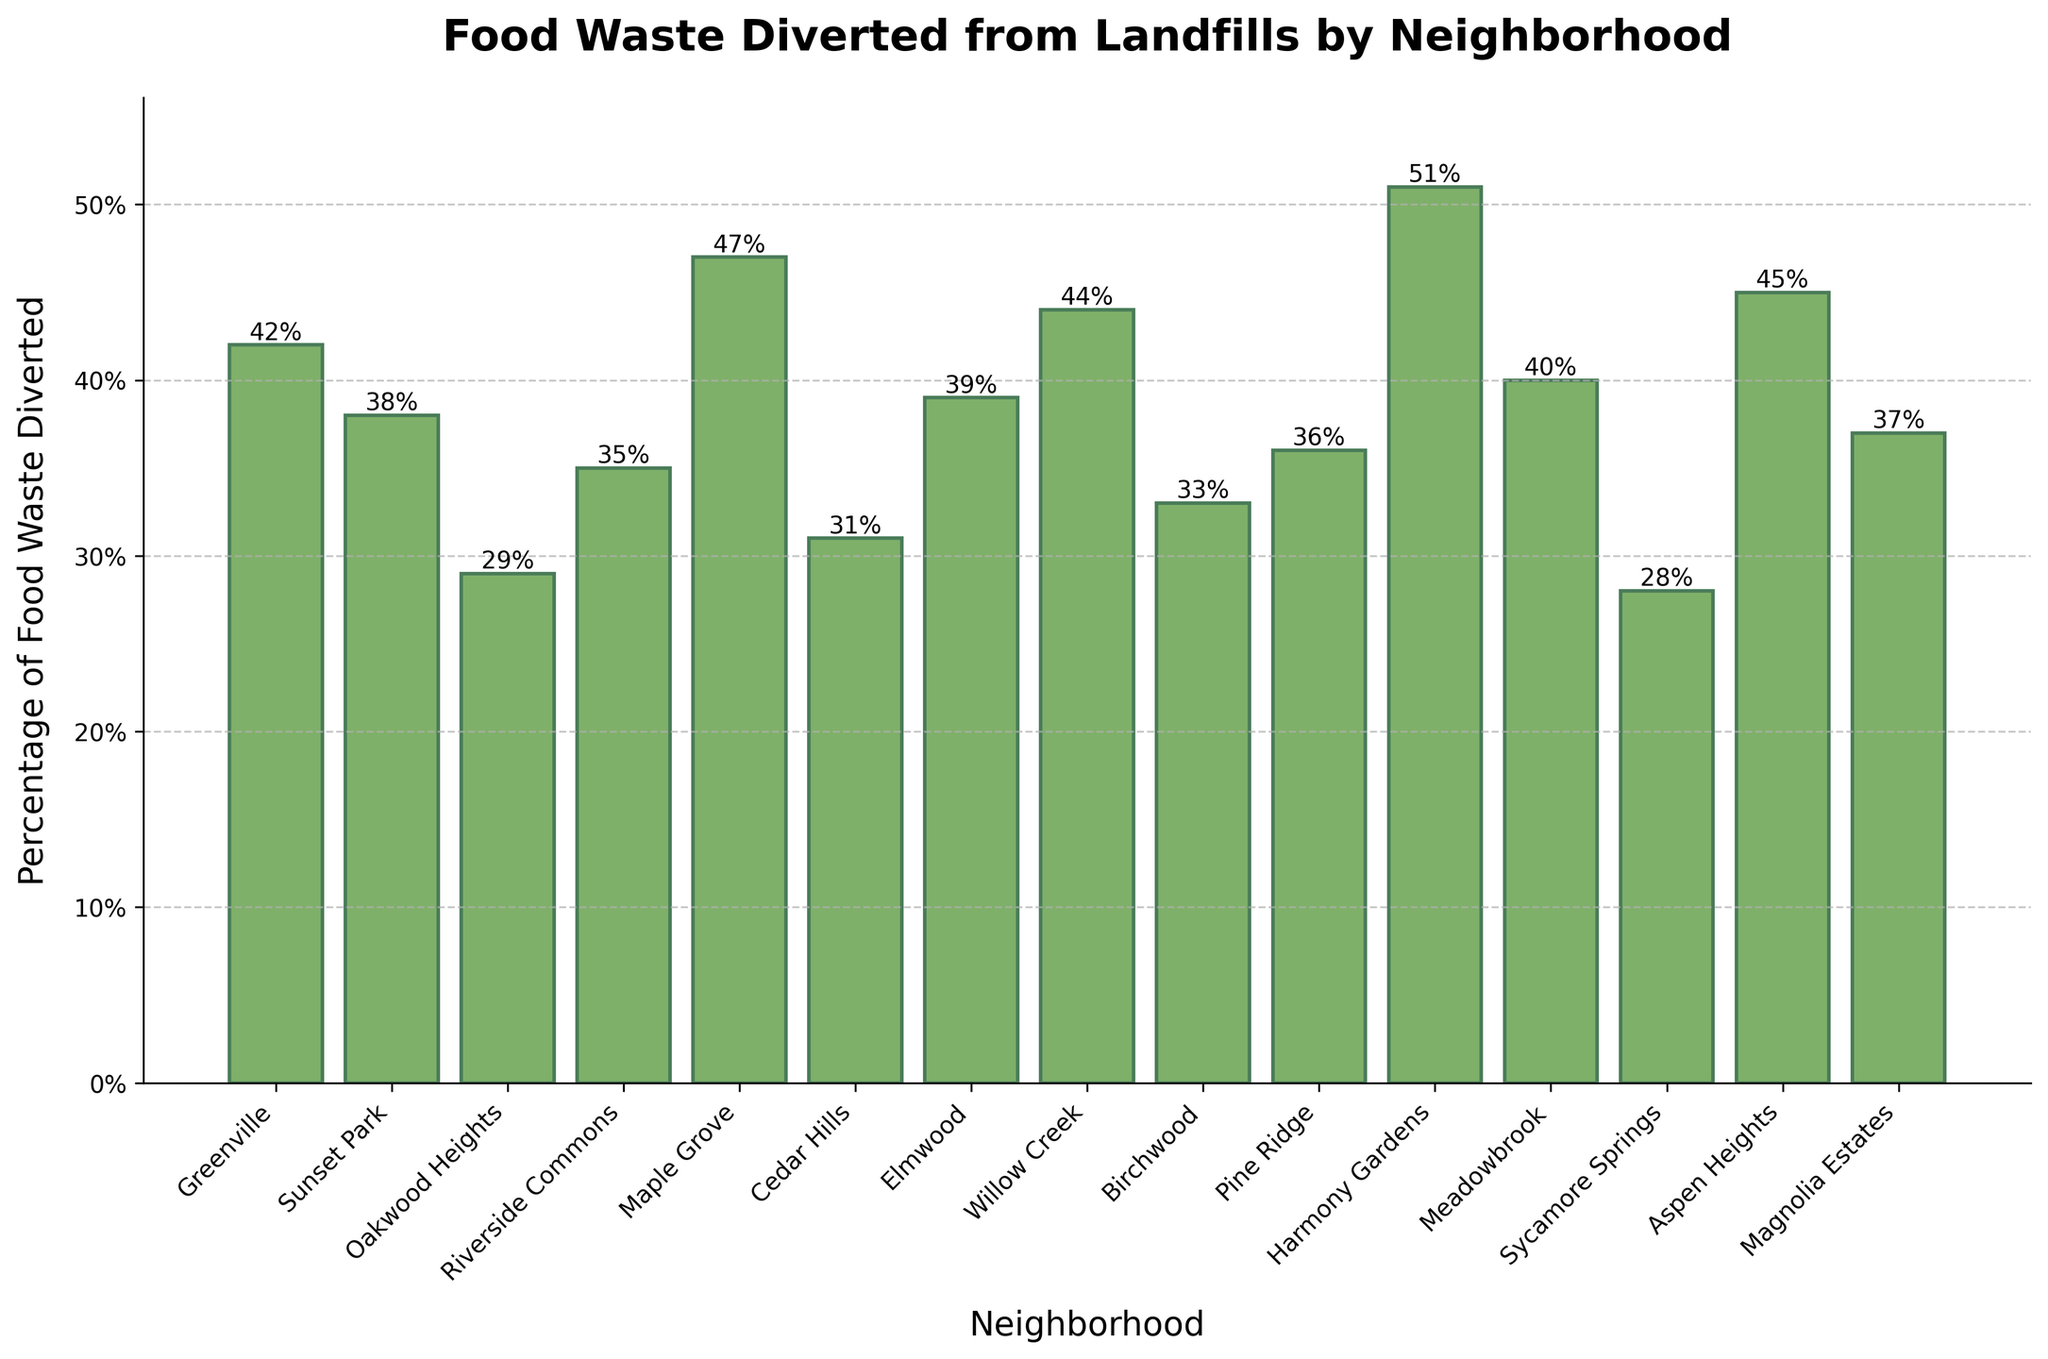Which neighborhood has the highest percentage of food waste diverted? The highest bar in the figure indicates the neighborhood with the highest percentage of food waste diverted. The label at the top of this bar shows "51%", corresponding to Harmony Gardens.
Answer: Harmony Gardens Which neighborhood has the lowest percentage of food waste diverted? The shortest bar indicates the neighborhood with the lowest percentage of food waste diverted. The label at the top of this bar shows "28%", corresponding to Sycamore Springs.
Answer: Sycamore Springs What is the difference between the highest and the lowest percentage of food waste diverted among the neighborhoods? The highest percentage is 51% (Harmony Gardens) and the lowest is 28% (Sycamore Springs). Subtracting the lowest value from the highest value gives 51% - 28% = 23%.
Answer: 23% How many neighborhoods have diverted between 30% and 40% of their food waste? Check the height of each bar and count those with values between 30% and 40% inclusive. The neighborhoods that fall in this range are Elmwood (39%), Pine Ridge (36%), Cedar Hills (31%), Magnolia Estates (37%), and Meadowbrook (40%) – a total of five.
Answer: 5 Which neighborhood has a percentage closest to the average percentage of food waste diverted across all neighborhoods? First, calculate the average percentage by summing all the percentages and dividing by the number of neighborhoods. Then, find the neighborhood whose percentage is closest to this average. The calculation goes as: (42 + 38 + 29 + 35 + 47 + 31 + 39 + 44 + 33 + 36 + 51 + 40 + 28 + 45 + 37) / 15 = 38.4%. The closest is Sunset Park with 38%.
Answer: Sunset Park Which neighborhoods have percentages greater than 40%? Identify and list all neighborhoods with a bar exceeding the 40% mark. These neighborhoods are Greenville (42%), Maple Grove (47%), Willow Creek (44%), Harmony Gardens (51%), Aspen Heights (45%), and Meadowbrook (40%).
Answer: Greenville, Maple Grove, Willow Creek, Harmony Gardens, Aspen Heights, Meadowbrook What is the median value of the percentages of food waste diverted? Arrange all percentages in ascending order and find the median (middle) value since there are an odd number of 15 neighborhoods. The ordered percentages are: 28, 29, 31, 33, 35, 36, 37, 38, 39, 40, 42, 44, 45, 47, 51. The median value is the 8th term, which is 38%.
Answer: 38% How much higher is the percentage of food waste diverted in Willow Creek compared to Cedar Hills? Find the percentages for Willow Creek and Cedar Hills and calculate the difference. Willow Creek is at 44% and Cedar Hills at 31%. The difference is 44% - 31% = 13%.
Answer: 13% Which neighborhood has a percentage value exactly in the middle of the range of percentages of food waste diverted? First, identify the range by subtracting the lowest percentage (28%) from the highest (51%). The midpoint is (51% + 28%) / 2 = 39.5%. Closest to this value are Elmwood (39%) and Meadowbrook (40%), but Meadowbrook is more central.
Answer: Meadowbrook 